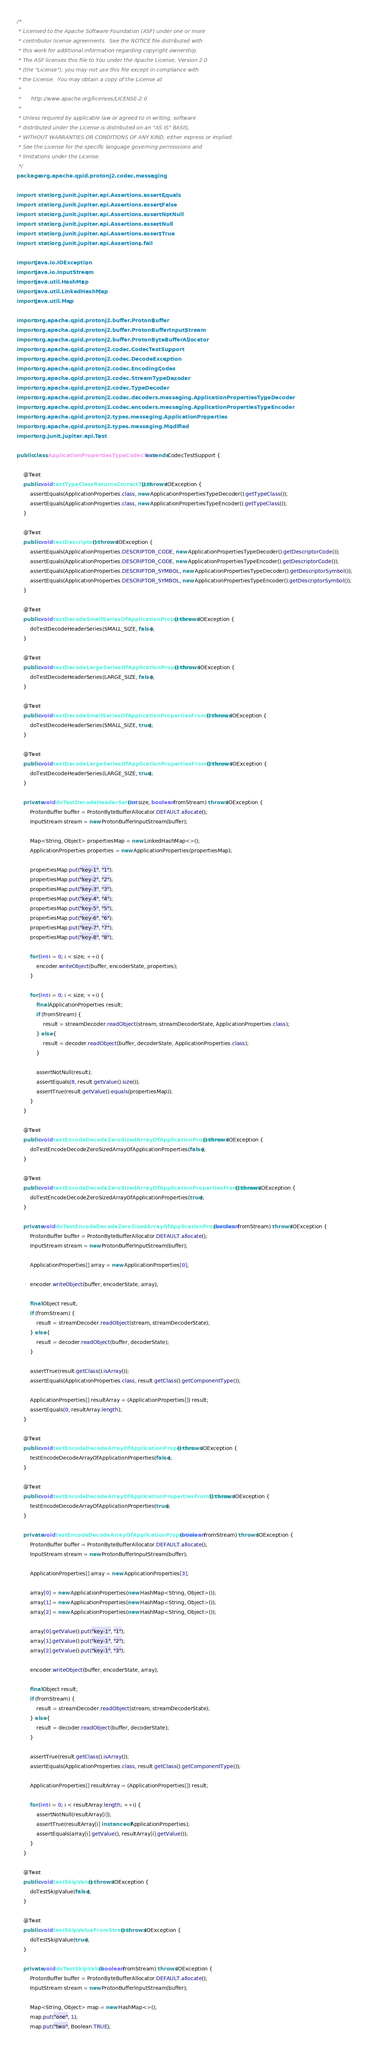<code> <loc_0><loc_0><loc_500><loc_500><_Java_>/*
 * Licensed to the Apache Software Foundation (ASF) under one or more
 * contributor license agreements.  See the NOTICE file distributed with
 * this work for additional information regarding copyright ownership.
 * The ASF licenses this file to You under the Apache License, Version 2.0
 * (the "License"); you may not use this file except in compliance with
 * the License.  You may obtain a copy of the License at
 *
 *      http://www.apache.org/licenses/LICENSE-2.0
 *
 * Unless required by applicable law or agreed to in writing, software
 * distributed under the License is distributed on an "AS IS" BASIS,
 * WITHOUT WARRANTIES OR CONDITIONS OF ANY KIND, either express or implied.
 * See the License for the specific language governing permissions and
 * limitations under the License.
 */
package org.apache.qpid.protonj2.codec.messaging;

import static org.junit.jupiter.api.Assertions.assertEquals;
import static org.junit.jupiter.api.Assertions.assertFalse;
import static org.junit.jupiter.api.Assertions.assertNotNull;
import static org.junit.jupiter.api.Assertions.assertNull;
import static org.junit.jupiter.api.Assertions.assertTrue;
import static org.junit.jupiter.api.Assertions.fail;

import java.io.IOException;
import java.io.InputStream;
import java.util.HashMap;
import java.util.LinkedHashMap;
import java.util.Map;

import org.apache.qpid.protonj2.buffer.ProtonBuffer;
import org.apache.qpid.protonj2.buffer.ProtonBufferInputStream;
import org.apache.qpid.protonj2.buffer.ProtonByteBufferAllocator;
import org.apache.qpid.protonj2.codec.CodecTestSupport;
import org.apache.qpid.protonj2.codec.DecodeException;
import org.apache.qpid.protonj2.codec.EncodingCodes;
import org.apache.qpid.protonj2.codec.StreamTypeDecoder;
import org.apache.qpid.protonj2.codec.TypeDecoder;
import org.apache.qpid.protonj2.codec.decoders.messaging.ApplicationPropertiesTypeDecoder;
import org.apache.qpid.protonj2.codec.encoders.messaging.ApplicationPropertiesTypeEncoder;
import org.apache.qpid.protonj2.types.messaging.ApplicationProperties;
import org.apache.qpid.protonj2.types.messaging.Modified;
import org.junit.jupiter.api.Test;

public class ApplicationPropertiesTypeCodecTest extends CodecTestSupport {

    @Test
    public void testTypeClassReturnsCorrectType() throws IOException {
        assertEquals(ApplicationProperties.class, new ApplicationPropertiesTypeDecoder().getTypeClass());
        assertEquals(ApplicationProperties.class, new ApplicationPropertiesTypeEncoder().getTypeClass());
    }

    @Test
    public void testDescriptors() throws IOException {
        assertEquals(ApplicationProperties.DESCRIPTOR_CODE, new ApplicationPropertiesTypeDecoder().getDescriptorCode());
        assertEquals(ApplicationProperties.DESCRIPTOR_CODE, new ApplicationPropertiesTypeEncoder().getDescriptorCode());
        assertEquals(ApplicationProperties.DESCRIPTOR_SYMBOL, new ApplicationPropertiesTypeDecoder().getDescriptorSymbol());
        assertEquals(ApplicationProperties.DESCRIPTOR_SYMBOL, new ApplicationPropertiesTypeEncoder().getDescriptorSymbol());
    }

    @Test
    public void testDecodeSmallSeriesOfApplicationProperties() throws IOException {
        doTestDecodeHeaderSeries(SMALL_SIZE, false);
    }

    @Test
    public void testDecodeLargeSeriesOfApplicationProperties() throws IOException {
        doTestDecodeHeaderSeries(LARGE_SIZE, false);
    }

    @Test
    public void testDecodeSmallSeriesOfApplicationPropertiesFromStream() throws IOException {
        doTestDecodeHeaderSeries(SMALL_SIZE, true);
    }

    @Test
    public void testDecodeLargeSeriesOfApplicationPropertiesFromStream() throws IOException {
        doTestDecodeHeaderSeries(LARGE_SIZE, true);
    }

    private void doTestDecodeHeaderSeries(int size, boolean fromStream) throws IOException {
        ProtonBuffer buffer = ProtonByteBufferAllocator.DEFAULT.allocate();
        InputStream stream = new ProtonBufferInputStream(buffer);

        Map<String, Object> propertiesMap = new LinkedHashMap<>();
        ApplicationProperties properties = new ApplicationProperties(propertiesMap);

        propertiesMap.put("key-1", "1");
        propertiesMap.put("key-2", "2");
        propertiesMap.put("key-3", "3");
        propertiesMap.put("key-4", "4");
        propertiesMap.put("key-5", "5");
        propertiesMap.put("key-6", "6");
        propertiesMap.put("key-7", "7");
        propertiesMap.put("key-8", "8");

        for (int i = 0; i < size; ++i) {
            encoder.writeObject(buffer, encoderState, properties);
        }

        for (int i = 0; i < size; ++i) {
            final ApplicationProperties result;
            if (fromStream) {
                result = streamDecoder.readObject(stream, streamDecoderState, ApplicationProperties.class);
            } else {
                result = decoder.readObject(buffer, decoderState, ApplicationProperties.class);
            }

            assertNotNull(result);
            assertEquals(8, result.getValue().size());
            assertTrue(result.getValue().equals(propertiesMap));
        }
    }

    @Test
    public void testEncodeDecodeZeroSizedArrayOfApplicationProperties() throws IOException {
        doTestEncodeDecodeZeroSizedArrayOfApplicationProperties(false);
    }

    @Test
    public void testEncodeDecodeZeroSizedArrayOfApplicationPropertiesFromStream() throws IOException {
        doTestEncodeDecodeZeroSizedArrayOfApplicationProperties(true);
    }

    private void doTestEncodeDecodeZeroSizedArrayOfApplicationProperties(boolean fromStream) throws IOException {
        ProtonBuffer buffer = ProtonByteBufferAllocator.DEFAULT.allocate();
        InputStream stream = new ProtonBufferInputStream(buffer);

        ApplicationProperties[] array = new ApplicationProperties[0];

        encoder.writeObject(buffer, encoderState, array);

        final Object result;
        if (fromStream) {
            result = streamDecoder.readObject(stream, streamDecoderState);
        } else {
            result = decoder.readObject(buffer, decoderState);
        }

        assertTrue(result.getClass().isArray());
        assertEquals(ApplicationProperties.class, result.getClass().getComponentType());

        ApplicationProperties[] resultArray = (ApplicationProperties[]) result;
        assertEquals(0, resultArray.length);
    }

    @Test
    public void testEncodeDecodeArrayOfApplicationProperties() throws IOException {
        testEncodeDecodeArrayOfApplicationProperties(false);
    }

    @Test
    public void testEncodeDecodeArrayOfApplicationPropertiesFromStream() throws IOException {
        testEncodeDecodeArrayOfApplicationProperties(true);
    }

    private void testEncodeDecodeArrayOfApplicationProperties(boolean fromStream) throws IOException {
        ProtonBuffer buffer = ProtonByteBufferAllocator.DEFAULT.allocate();
        InputStream stream = new ProtonBufferInputStream(buffer);

        ApplicationProperties[] array = new ApplicationProperties[3];

        array[0] = new ApplicationProperties(new HashMap<String, Object>());
        array[1] = new ApplicationProperties(new HashMap<String, Object>());
        array[2] = new ApplicationProperties(new HashMap<String, Object>());

        array[0].getValue().put("key-1", "1");
        array[1].getValue().put("key-1", "2");
        array[2].getValue().put("key-1", "3");

        encoder.writeObject(buffer, encoderState, array);

        final Object result;
        if (fromStream) {
            result = streamDecoder.readObject(stream, streamDecoderState);
        } else {
            result = decoder.readObject(buffer, decoderState);
        }

        assertTrue(result.getClass().isArray());
        assertEquals(ApplicationProperties.class, result.getClass().getComponentType());

        ApplicationProperties[] resultArray = (ApplicationProperties[]) result;

        for (int i = 0; i < resultArray.length; ++i) {
            assertNotNull(resultArray[i]);
            assertTrue(resultArray[i] instanceof ApplicationProperties);
            assertEquals(array[i].getValue(), resultArray[i].getValue());
        }
    }

    @Test
    public void testSkipValue() throws IOException {
        doTestSkipValue(false);
    }

    @Test
    public void testSkipValueFromStream() throws IOException {
        doTestSkipValue(true);
    }

    private void doTestSkipValue(boolean fromStream) throws IOException {
        ProtonBuffer buffer = ProtonByteBufferAllocator.DEFAULT.allocate();
        InputStream stream = new ProtonBufferInputStream(buffer);

        Map<String, Object> map = new HashMap<>();
        map.put("one", 1);
        map.put("two", Boolean.TRUE);</code> 